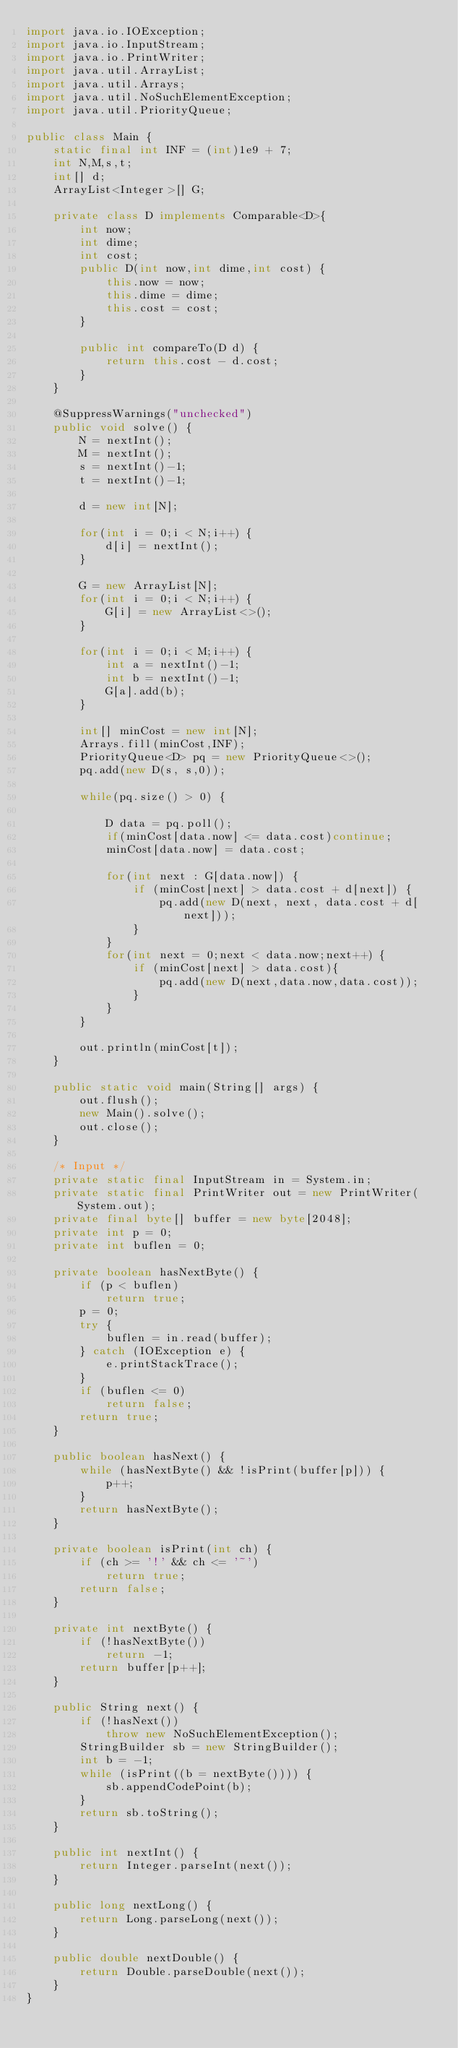<code> <loc_0><loc_0><loc_500><loc_500><_Java_>import java.io.IOException;
import java.io.InputStream;
import java.io.PrintWriter;
import java.util.ArrayList;
import java.util.Arrays;
import java.util.NoSuchElementException;
import java.util.PriorityQueue;

public class Main {
    static final int INF = (int)1e9 + 7;
    int N,M,s,t;
    int[] d;
    ArrayList<Integer>[] G;

    private class D implements Comparable<D>{
        int now;
        int dime;
        int cost;
        public D(int now,int dime,int cost) {
            this.now = now;
            this.dime = dime;
            this.cost = cost;
        }

        public int compareTo(D d) {
            return this.cost - d.cost;
        }
    }

    @SuppressWarnings("unchecked")
    public void solve() {
        N = nextInt();
        M = nextInt();
        s = nextInt()-1;
        t = nextInt()-1;

        d = new int[N];

        for(int i = 0;i < N;i++) {
            d[i] = nextInt();
        }

        G = new ArrayList[N];
        for(int i = 0;i < N;i++) {
            G[i] = new ArrayList<>();
        }

        for(int i = 0;i < M;i++) {
            int a = nextInt()-1;
            int b = nextInt()-1;
            G[a].add(b);
        }

        int[] minCost = new int[N];
        Arrays.fill(minCost,INF);
        PriorityQueue<D> pq = new PriorityQueue<>();
        pq.add(new D(s, s,0));

        while(pq.size() > 0) {

            D data = pq.poll();
            if(minCost[data.now] <= data.cost)continue;
            minCost[data.now] = data.cost;

            for(int next : G[data.now]) {
                if (minCost[next] > data.cost + d[next]) {
                    pq.add(new D(next, next, data.cost + d[next]));
                }
            }
            for(int next = 0;next < data.now;next++) {
                if (minCost[next] > data.cost){
                    pq.add(new D(next,data.now,data.cost));
                }
            }
        }

        out.println(minCost[t]);
    }

    public static void main(String[] args) {
        out.flush();
        new Main().solve();
        out.close();
    }

    /* Input */
    private static final InputStream in = System.in;
    private static final PrintWriter out = new PrintWriter(System.out);
    private final byte[] buffer = new byte[2048];
    private int p = 0;
    private int buflen = 0;

    private boolean hasNextByte() {
        if (p < buflen)
            return true;
        p = 0;
        try {
            buflen = in.read(buffer);
        } catch (IOException e) {
            e.printStackTrace();
        }
        if (buflen <= 0)
            return false;
        return true;
    }

    public boolean hasNext() {
        while (hasNextByte() && !isPrint(buffer[p])) {
            p++;
        }
        return hasNextByte();
    }

    private boolean isPrint(int ch) {
        if (ch >= '!' && ch <= '~')
            return true;
        return false;
    }

    private int nextByte() {
        if (!hasNextByte())
            return -1;
        return buffer[p++];
    }

    public String next() {
        if (!hasNext())
            throw new NoSuchElementException();
        StringBuilder sb = new StringBuilder();
        int b = -1;
        while (isPrint((b = nextByte()))) {
            sb.appendCodePoint(b);
        }
        return sb.toString();
    }

    public int nextInt() {
        return Integer.parseInt(next());
    }

    public long nextLong() {
        return Long.parseLong(next());
    }

    public double nextDouble() {
        return Double.parseDouble(next());
    }
}</code> 